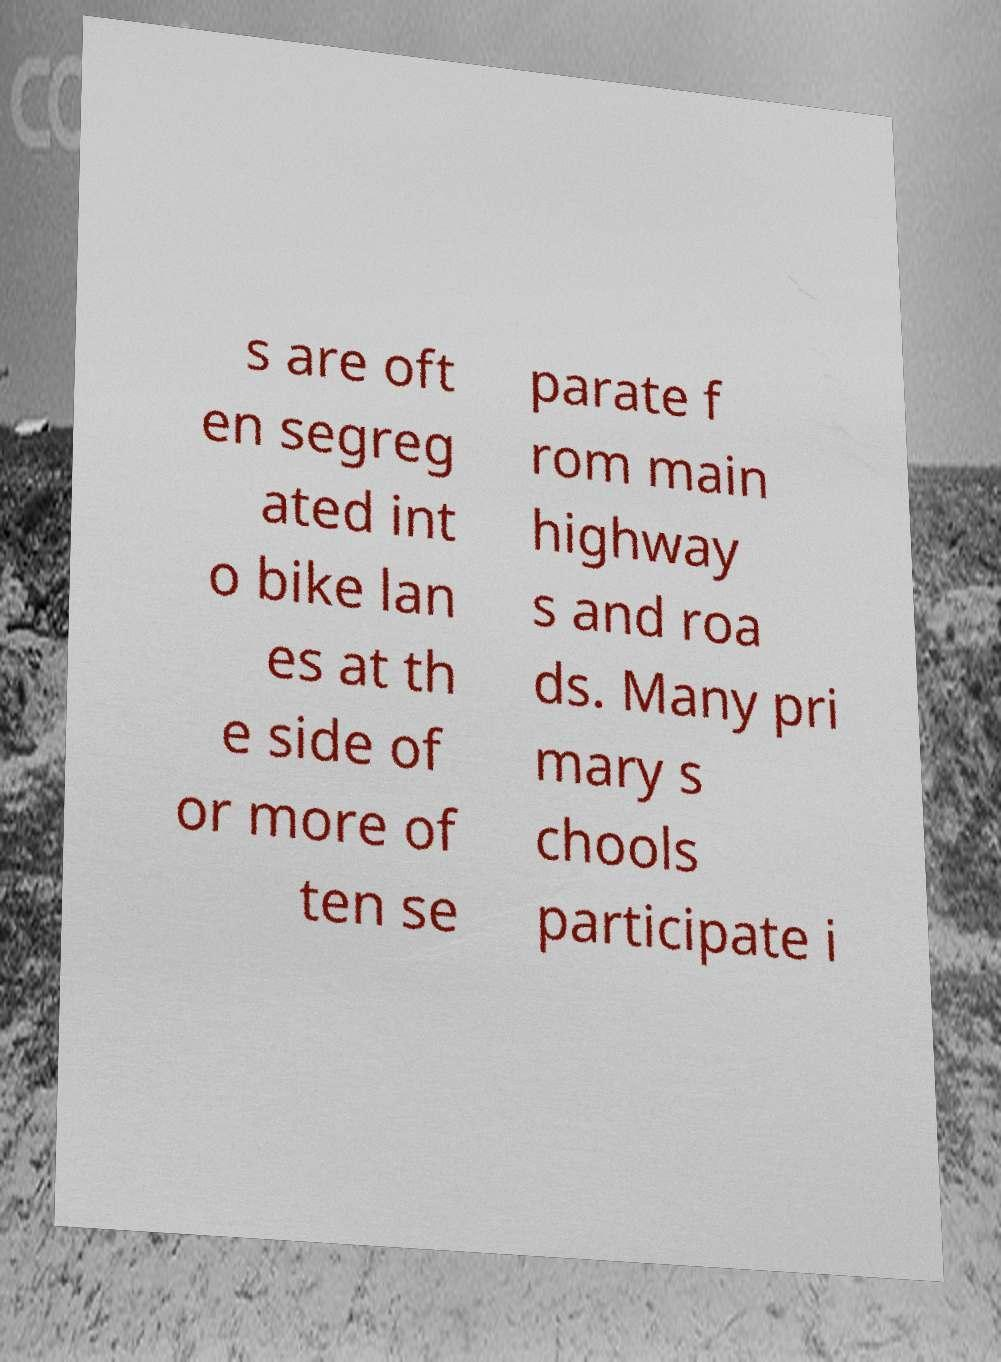Please read and relay the text visible in this image. What does it say? s are oft en segreg ated int o bike lan es at th e side of or more of ten se parate f rom main highway s and roa ds. Many pri mary s chools participate i 